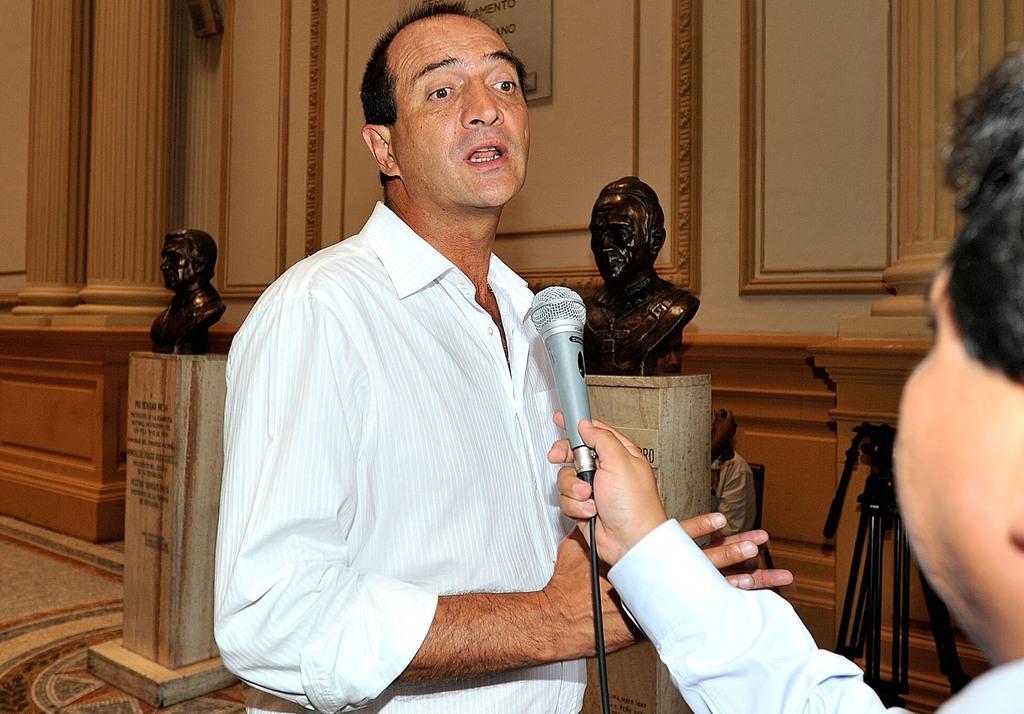Describe this image in one or two sentences. A man is speaking with a mic in front of him. Another man is holding a mic in front. There are two statues in the background. 